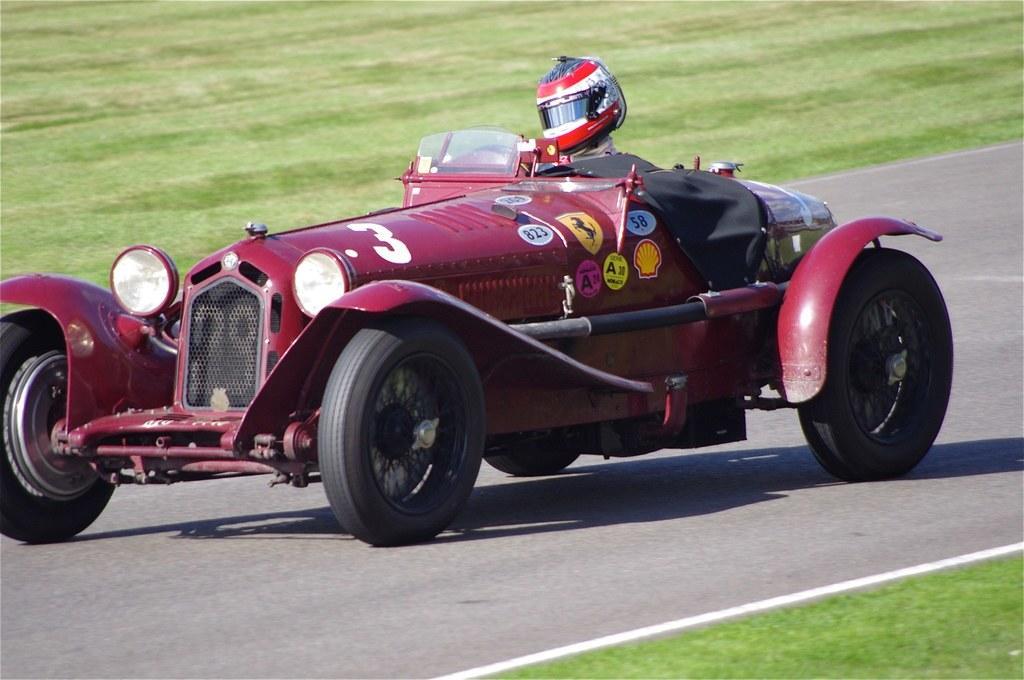Can you describe this image briefly? In this image we can see a vehicle on the road. We can see a man in the vehicle. On the both sides of the road, we can see grassy land. 